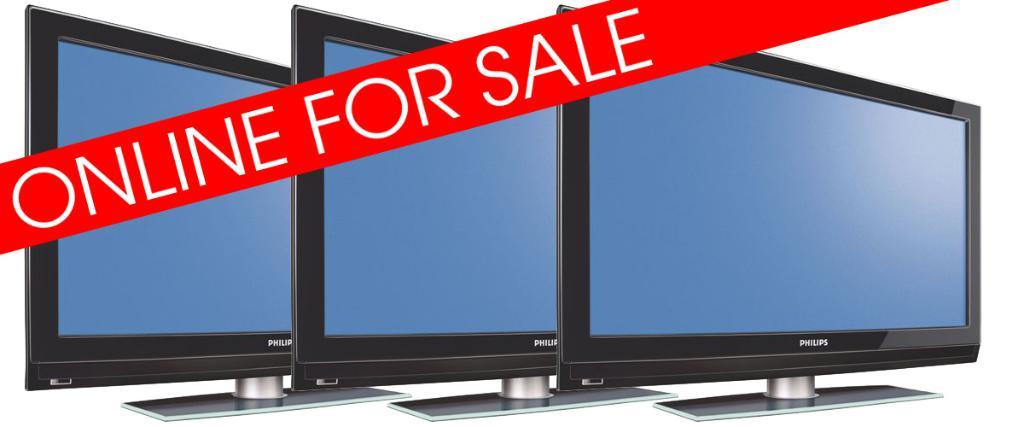Provide a one-sentence caption for the provided image. Three flat screen TVs are advertised as being on sale. 